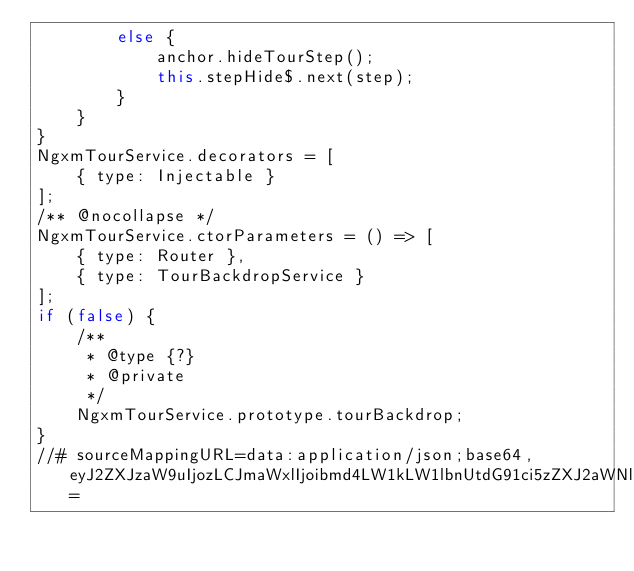<code> <loc_0><loc_0><loc_500><loc_500><_JavaScript_>        else {
            anchor.hideTourStep();
            this.stepHide$.next(step);
        }
    }
}
NgxmTourService.decorators = [
    { type: Injectable }
];
/** @nocollapse */
NgxmTourService.ctorParameters = () => [
    { type: Router },
    { type: TourBackdropService }
];
if (false) {
    /**
     * @type {?}
     * @private
     */
    NgxmTourService.prototype.tourBackdrop;
}
//# sourceMappingURL=data:application/json;base64,eyJ2ZXJzaW9uIjozLCJmaWxlIjoibmd4LW1kLW1lbnUtdG91ci5zZXJ2aWNlLmpzIiwic291cmNlUm9vdCI6Im5nOi8vbmd4LXRvdXItbWQtbWVudS8iLCJzb3VyY2VzIjpbImxpYi9uZ3gtbWQtbWVudS10b3VyLnNlcnZpY2UudHMiXSwibmFtZXMiOltdLCJtYXBwaW5ncyI6Ijs7OztBQUFBLE9BQU8sRUFBRSxVQUFVLEVBQUUsTUFBTSxlQUFlLENBQUM7QUFDM0MsT0FBTyxFQUFFLFdBQVcsRUFBRSxNQUFNLGVBQWUsQ0FBQztBQUc1QyxPQUFPLEVBQUUsbUJBQW1CLEVBQUUsTUFBTSx5QkFBeUIsQ0FBQztBQUM5RCxPQUFPLEVBQUUsTUFBTSxFQUFFLE1BQU0saUJBQWlCLENBQUM7QUFHekMsTUFBTSxPQUFPLGVBQWdCLFNBQVEsV0FBNEI7Ozs7O0lBRS9ELFlBQ0UsTUFBYyxFQUNOLFlBQWlDO1FBRXpDLEtBQUssQ0FBQyxNQUFNLENBQUMsQ0FBQztRQUZOLGlCQUFZLEdBQVosWUFBWSxDQUFxQjtJQUczQyxDQUFDOzs7Ozs7SUFFUyxRQUFRLENBQUMsSUFBSTs7Y0FDZixNQUFNLEdBQUcsSUFBSSxDQUFDLE9BQU8sQ0FBQyxJQUFJLElBQUksSUFBSSxDQUFDLFFBQVEsQ0FBQztRQUNsRCxJQUFJLENBQUMsTUFBTSxFQUFFO1lBQ1gsSUFBSSxDQUFDLFlBQVksQ0FBQyxLQUFLLEVBQUUsQ0FBQztTQUMzQjthQUFNO1lBQ0wsTUFBTSxDQUFDLFlBQVksRUFBRSxDQUFDO1lBQ3RCLElBQUksQ0FBQyxTQUFTLENBQUMsSUFBSSxDQUFDLElBQUksQ0FBQyxDQUFDO1NBQzNCO0lBQ0gsQ0FBQzs7O1lBbEJGLFVBQVU7Ozs7WUFGRixNQUFNO1lBRE4sbUJBQW1COzs7Ozs7O0lBUXhCLHVDQUF5QyIsInNvdXJjZXNDb250ZW50IjpbImltcG9ydCB7IEluamVjdGFibGUgfSBmcm9tICdAYW5ndWxhci9jb3JlJztcclxuaW1wb3J0IHsgVG91clNlcnZpY2UgfSBmcm9tICduZ3gtdG91ci1jb3JlJztcclxuXHJcbmltcG9ydCB7IElOZ3htU3RlcE9wdGlvbiB9IGZyb20gJy4vc3RlcC1vcHRpb24uaW50ZXJmYWNlJztcclxuaW1wb3J0IHsgVG91ckJhY2tkcm9wU2VydmljZSB9IGZyb20gJy4vdG91ci1iYWNrZHJvcC5zZXJ2aWNlJztcclxuaW1wb3J0IHsgUm91dGVyIH0gZnJvbSAnQGFuZ3VsYXIvcm91dGVyJztcclxuXHJcbkBJbmplY3RhYmxlKClcclxuZXhwb3J0IGNsYXNzIE5neG1Ub3VyU2VydmljZSBleHRlbmRzIFRvdXJTZXJ2aWNlPElOZ3htU3RlcE9wdGlvbj4ge1xyXG5cclxuICBjb25zdHJ1Y3RvcihcclxuICAgIHJvdXRlcjogUm91dGVyLFxyXG4gICAgcHJpdmF0ZSB0b3VyQmFja2Ryb3A6IFRvdXJCYWNrZHJvcFNlcnZpY2VcclxuICApIHtcclxuICAgIHN1cGVyKHJvdXRlcik7XHJcbiAgfVxyXG5cclxuICBwcm90ZWN0ZWQgaGlkZVN0ZXAoc3RlcCk6IHZvaWQge1xyXG4gICAgY29uc3QgYW5jaG9yID0gdGhpcy5hbmNob3JzW3N0ZXAgJiYgc3RlcC5hbmNob3JJZF07XHJcbiAgICBpZiAoIWFuY2hvcikge1xyXG4gICAgICB0aGlzLnRvdXJCYWNrZHJvcC5jbG9zZSgpO1xyXG4gICAgfSBlbHNlIHtcclxuICAgICAgYW5jaG9yLmhpZGVUb3VyU3RlcCgpO1xyXG4gICAgICB0aGlzLnN0ZXBIaWRlJC5uZXh0KHN0ZXApO1xyXG4gICAgfVxyXG4gIH1cclxufVxyXG4iXX0=</code> 